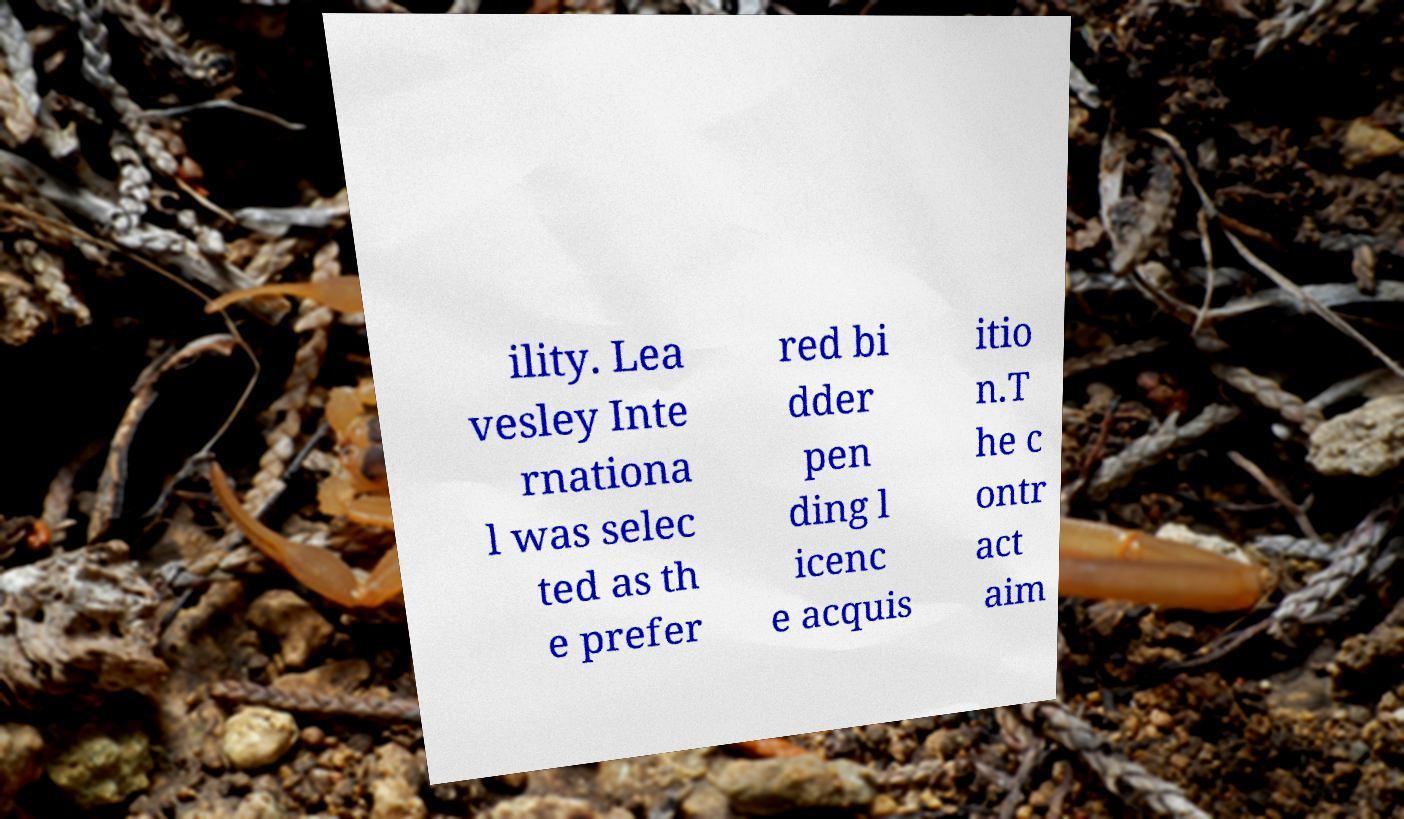Could you assist in decoding the text presented in this image and type it out clearly? ility. Lea vesley Inte rnationa l was selec ted as th e prefer red bi dder pen ding l icenc e acquis itio n.T he c ontr act aim 